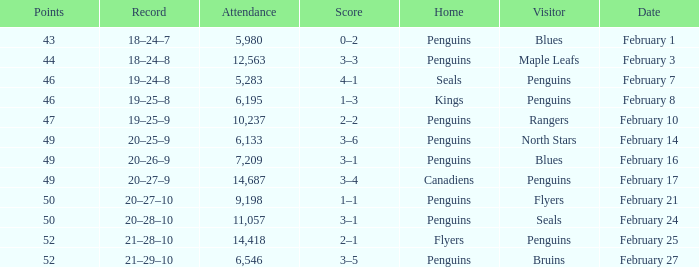Score of 2–1 has what record? 21–28–10. Can you give me this table as a dict? {'header': ['Points', 'Record', 'Attendance', 'Score', 'Home', 'Visitor', 'Date'], 'rows': [['43', '18–24–7', '5,980', '0–2', 'Penguins', 'Blues', 'February 1'], ['44', '18–24–8', '12,563', '3–3', 'Penguins', 'Maple Leafs', 'February 3'], ['46', '19–24–8', '5,283', '4–1', 'Seals', 'Penguins', 'February 7'], ['46', '19–25–8', '6,195', '1–3', 'Kings', 'Penguins', 'February 8'], ['47', '19–25–9', '10,237', '2–2', 'Penguins', 'Rangers', 'February 10'], ['49', '20–25–9', '6,133', '3–6', 'Penguins', 'North Stars', 'February 14'], ['49', '20–26–9', '7,209', '3–1', 'Penguins', 'Blues', 'February 16'], ['49', '20–27–9', '14,687', '3–4', 'Canadiens', 'Penguins', 'February 17'], ['50', '20–27–10', '9,198', '1–1', 'Penguins', 'Flyers', 'February 21'], ['50', '20–28–10', '11,057', '3–1', 'Penguins', 'Seals', 'February 24'], ['52', '21–28–10', '14,418', '2–1', 'Flyers', 'Penguins', 'February 25'], ['52', '21–29–10', '6,546', '3–5', 'Penguins', 'Bruins', 'February 27']]} 